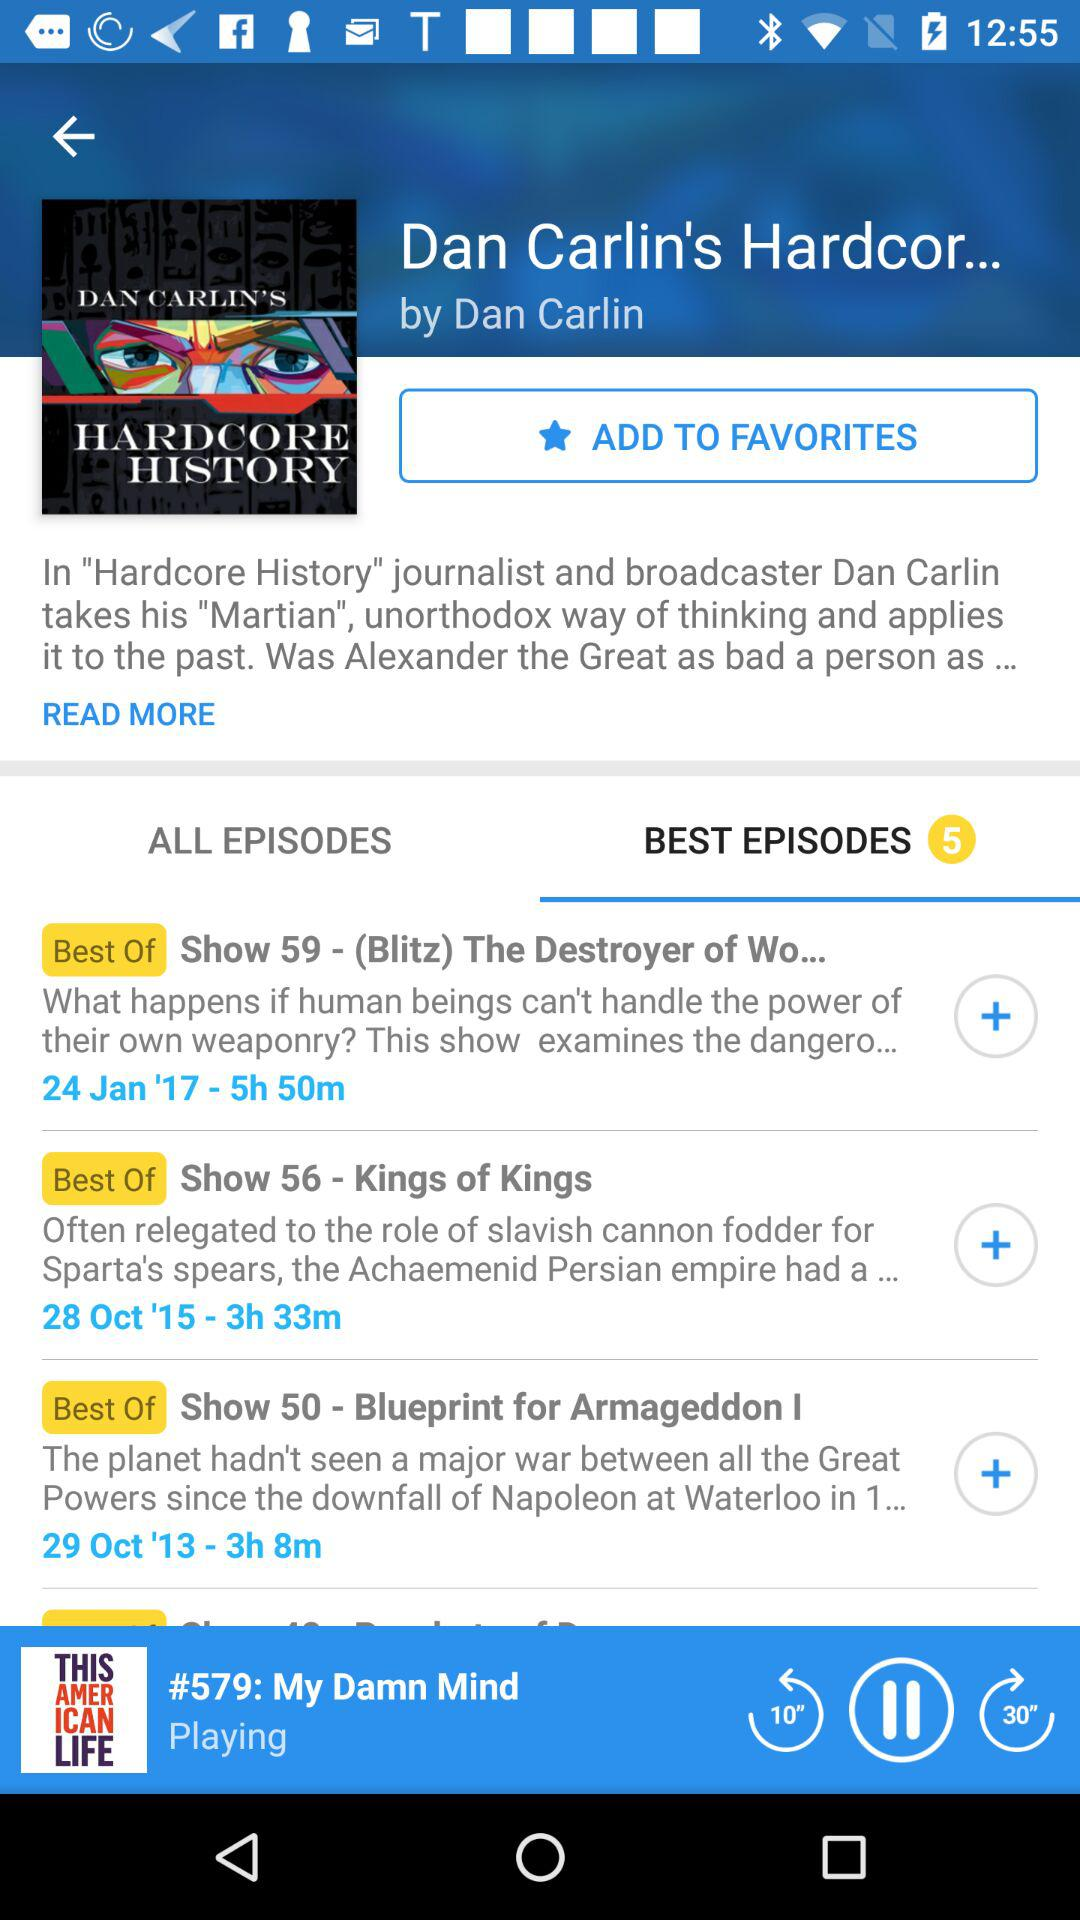What is the author name of "Hardcore History"? The author of "Hardcore History" is Dan Carlin. 